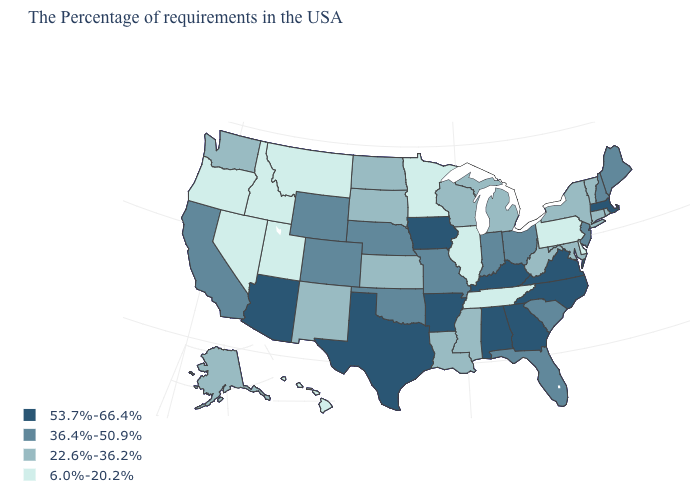Does Rhode Island have a higher value than Connecticut?
Keep it brief. No. Is the legend a continuous bar?
Write a very short answer. No. Is the legend a continuous bar?
Answer briefly. No. What is the lowest value in states that border Rhode Island?
Give a very brief answer. 22.6%-36.2%. Which states have the lowest value in the MidWest?
Quick response, please. Illinois, Minnesota. Among the states that border Maryland , does Pennsylvania have the lowest value?
Be succinct. Yes. Does Maine have a lower value than Iowa?
Be succinct. Yes. What is the highest value in the Northeast ?
Write a very short answer. 53.7%-66.4%. Name the states that have a value in the range 53.7%-66.4%?
Keep it brief. Massachusetts, Virginia, North Carolina, Georgia, Kentucky, Alabama, Arkansas, Iowa, Texas, Arizona. What is the value of Colorado?
Answer briefly. 36.4%-50.9%. Name the states that have a value in the range 53.7%-66.4%?
Answer briefly. Massachusetts, Virginia, North Carolina, Georgia, Kentucky, Alabama, Arkansas, Iowa, Texas, Arizona. What is the value of Utah?
Answer briefly. 6.0%-20.2%. What is the lowest value in the USA?
Write a very short answer. 6.0%-20.2%. What is the lowest value in states that border Wisconsin?
Keep it brief. 6.0%-20.2%. 